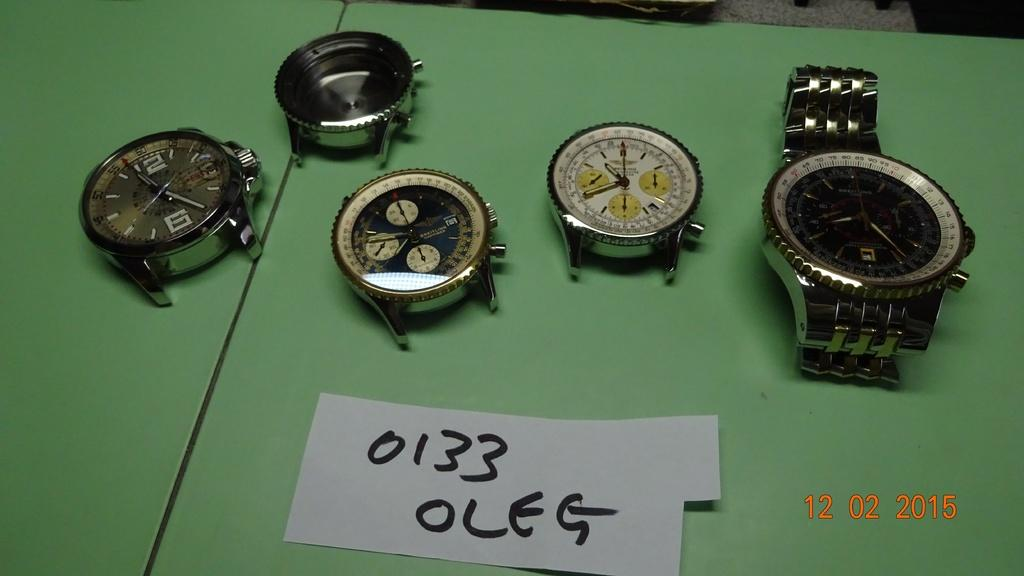Provide a one-sentence caption for the provided image. several watch pieces are laying on a green table with a paper saying 0133 OLEG. 